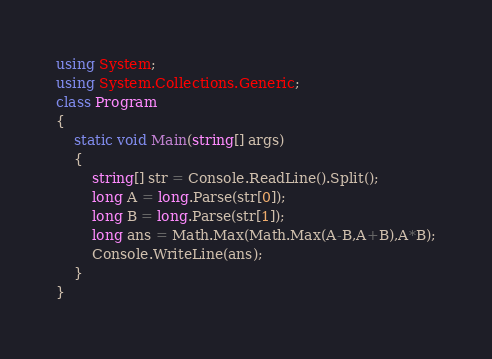<code> <loc_0><loc_0><loc_500><loc_500><_C#_>using System;
using System.Collections.Generic;
class Program
{
	static void Main(string[] args)
	{
		string[] str = Console.ReadLine().Split();
		long A = long.Parse(str[0]);
		long B = long.Parse(str[1]);
		long ans = Math.Max(Math.Max(A-B,A+B),A*B);
		Console.WriteLine(ans);
	}
}</code> 